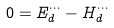Convert formula to latex. <formula><loc_0><loc_0><loc_500><loc_500>0 = E ^ { \cdots } _ { d } - H ^ { \cdots } _ { d }</formula> 